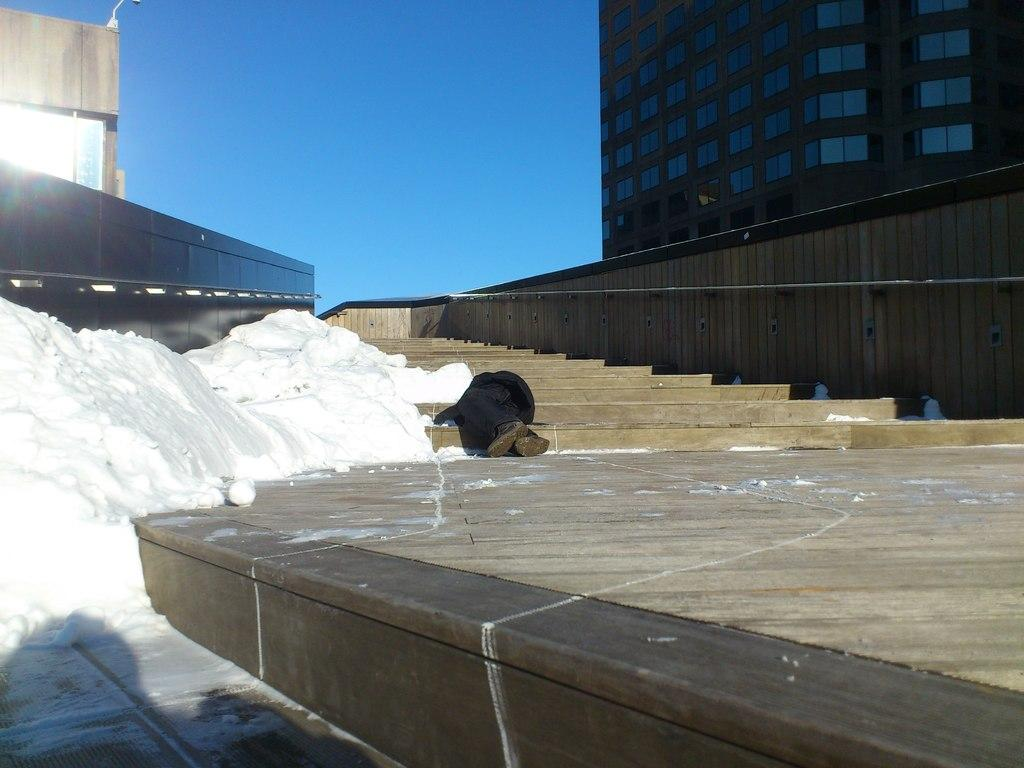What is the person in the image doing? The person is lying on the steps. What can be seen in the background of the image? There are buildings in the background of the image. What type of jewel is the person wearing on their forehead in the image? There is no jewel visible on the person's forehead in the image. 